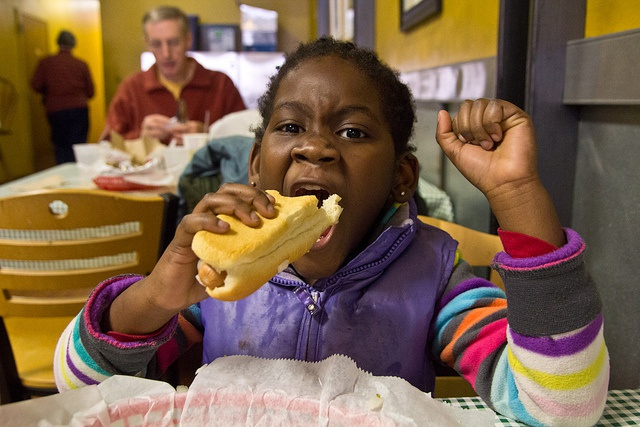Describe the objects in this image and their specific colors. I can see people in olive, black, and maroon tones, chair in olive, tan, and maroon tones, people in olive, maroon, and brown tones, hot dog in olive, gold, and orange tones, and people in olive, black, and maroon tones in this image. 